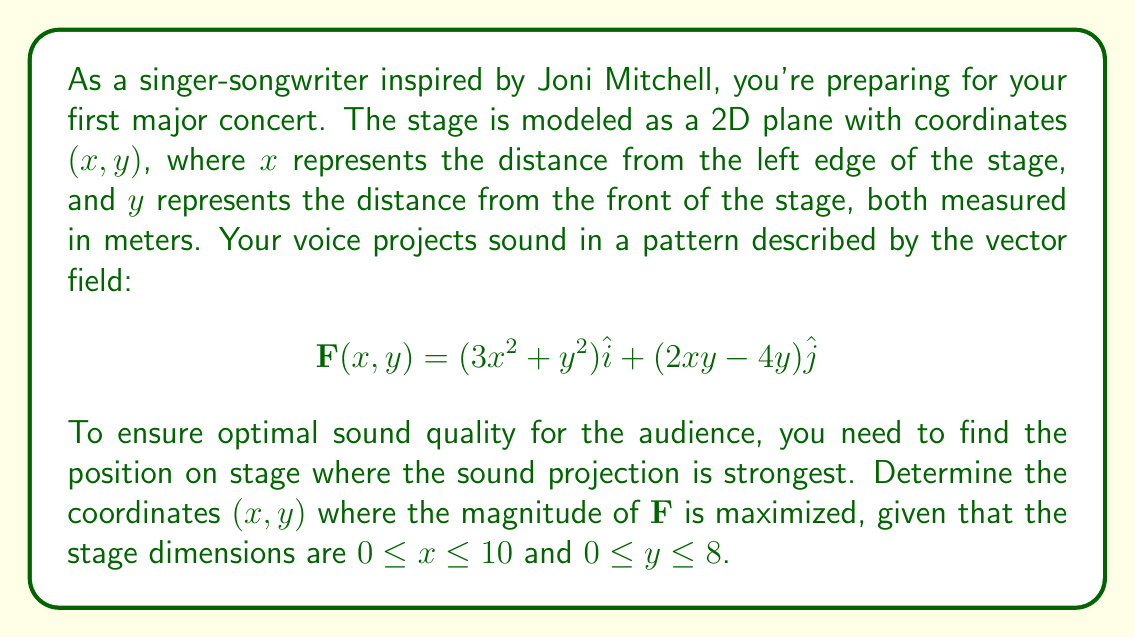Solve this math problem. To solve this problem, we'll follow these steps:

1) First, we need to find the magnitude of the vector field $\mathbf{F}$:

   $$|\mathbf{F}| = \sqrt{(3x^2 + y^2)^2 + (2xy - 4y)^2}$$

2) To find the maximum value of $|\mathbf{F}|$, we need to find the critical points by taking partial derivatives with respect to $x$ and $y$ and setting them equal to zero:

   $$\frac{\partial |\mathbf{F}|}{\partial x} = \frac{2(3x^2 + y^2)(6x) + 2(2xy - 4y)(2y)}{2\sqrt{(3x^2 + y^2)^2 + (2xy - 4y)^2}} = 0$$

   $$\frac{\partial |\mathbf{F}|}{\partial y} = \frac{2(3x^2 + y^2)(2y) + 2(2xy - 4y)(2x - 4)}{2\sqrt{(3x^2 + y^2)^2 + (2xy - 4y)^2}} = 0$$

3) Simplifying these equations:

   $$(3x^2 + y^2)(6x) + (2xy - 4y)(2y) = 0$$
   $$(3x^2 + y^2)(2y) + (2xy - 4y)(2x - 4) = 0$$

4) These equations are complex to solve analytically. In practice, we would use numerical methods to find the solution. However, given the context of the problem, we can make an educated guess that the maximum might occur at one of the corners of the stage.

5) Let's evaluate $|\mathbf{F}|$ at the four corners of the stage:

   At $(0,0)$: $|\mathbf{F}(0,0)| = 0$
   At $(10,0)$: $|\mathbf{F}(10,0)| = 300$
   At $(0,8)$: $|\mathbf{F}(0,8)| = \sqrt{64^2 + (-32)^2} = 72$
   At $(10,8)$: $|\mathbf{F}(10,8)| = \sqrt{364^2 + 96^2} = 376$

6) The maximum value among these points occurs at $(10,8)$, which corresponds to the back-right corner of the stage.

7) To ensure this is indeed the global maximum, we would need to check the interior critical points (if any exist) and compare their values to this corner point. However, given the increasing trend towards this corner, it's likely that $(10,8)$ is indeed the global maximum within the given domain.
Answer: The optimal microphone placement is at coordinates $(10,8)$, which represents the back-right corner of the stage. 